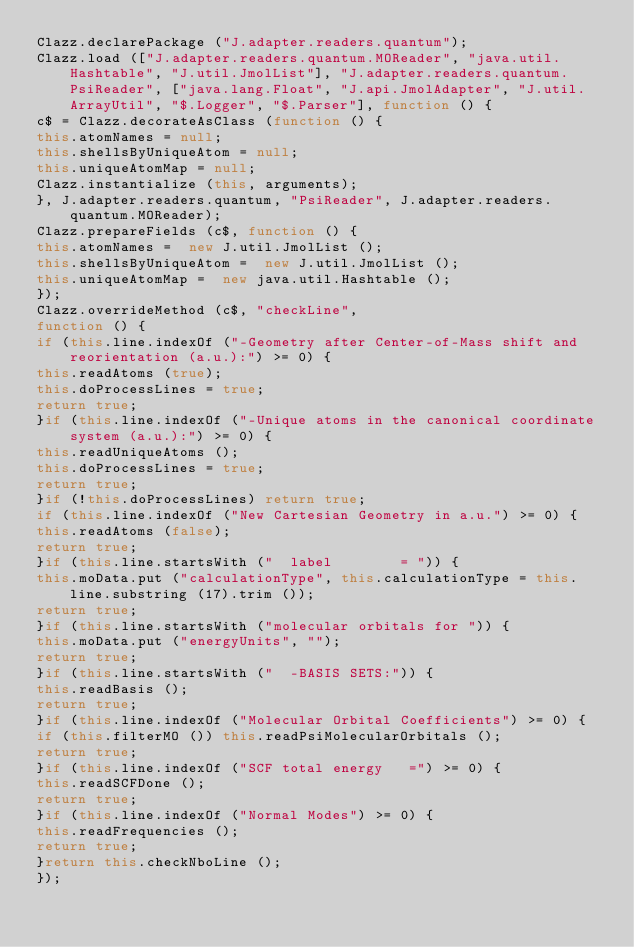Convert code to text. <code><loc_0><loc_0><loc_500><loc_500><_JavaScript_>Clazz.declarePackage ("J.adapter.readers.quantum");
Clazz.load (["J.adapter.readers.quantum.MOReader", "java.util.Hashtable", "J.util.JmolList"], "J.adapter.readers.quantum.PsiReader", ["java.lang.Float", "J.api.JmolAdapter", "J.util.ArrayUtil", "$.Logger", "$.Parser"], function () {
c$ = Clazz.decorateAsClass (function () {
this.atomNames = null;
this.shellsByUniqueAtom = null;
this.uniqueAtomMap = null;
Clazz.instantialize (this, arguments);
}, J.adapter.readers.quantum, "PsiReader", J.adapter.readers.quantum.MOReader);
Clazz.prepareFields (c$, function () {
this.atomNames =  new J.util.JmolList ();
this.shellsByUniqueAtom =  new J.util.JmolList ();
this.uniqueAtomMap =  new java.util.Hashtable ();
});
Clazz.overrideMethod (c$, "checkLine", 
function () {
if (this.line.indexOf ("-Geometry after Center-of-Mass shift and reorientation (a.u.):") >= 0) {
this.readAtoms (true);
this.doProcessLines = true;
return true;
}if (this.line.indexOf ("-Unique atoms in the canonical coordinate system (a.u.):") >= 0) {
this.readUniqueAtoms ();
this.doProcessLines = true;
return true;
}if (!this.doProcessLines) return true;
if (this.line.indexOf ("New Cartesian Geometry in a.u.") >= 0) {
this.readAtoms (false);
return true;
}if (this.line.startsWith ("  label        = ")) {
this.moData.put ("calculationType", this.calculationType = this.line.substring (17).trim ());
return true;
}if (this.line.startsWith ("molecular orbitals for ")) {
this.moData.put ("energyUnits", "");
return true;
}if (this.line.startsWith ("  -BASIS SETS:")) {
this.readBasis ();
return true;
}if (this.line.indexOf ("Molecular Orbital Coefficients") >= 0) {
if (this.filterMO ()) this.readPsiMolecularOrbitals ();
return true;
}if (this.line.indexOf ("SCF total energy   =") >= 0) {
this.readSCFDone ();
return true;
}if (this.line.indexOf ("Normal Modes") >= 0) {
this.readFrequencies ();
return true;
}return this.checkNboLine ();
});</code> 